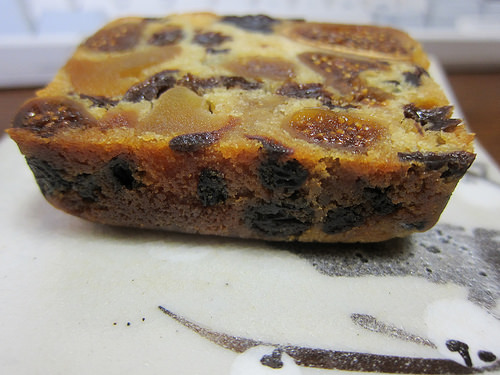<image>
Can you confirm if the chocolate chips is in the dessert? Yes. The chocolate chips is contained within or inside the dessert, showing a containment relationship. 